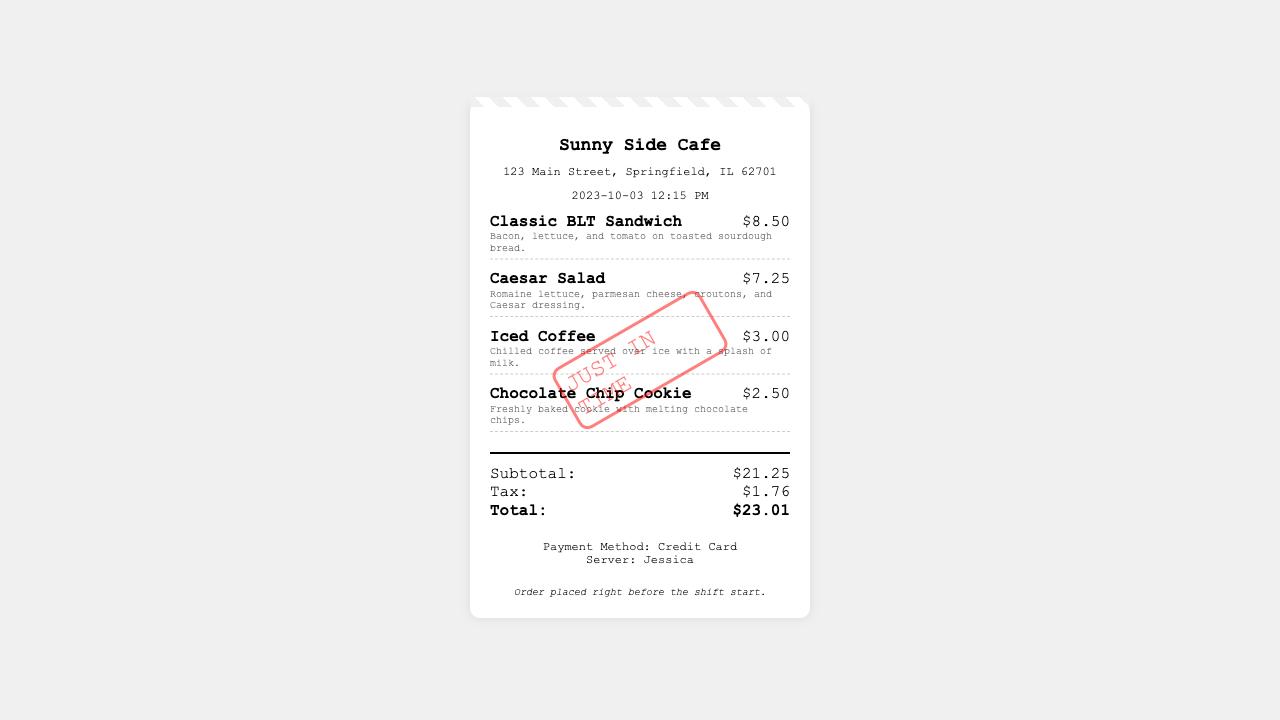What is the name of the cafe? The name of the cafe is prominently displayed at the top of the receipt.
Answer: Sunny Side Cafe What is the address of the cafe? The address is provided directly below the cafe's name.
Answer: 123 Main Street, Springfield, IL 62701 What is the date and time of the order? The date and time are specified below the cafe's address.
Answer: 2023-10-03 12:15 PM How much did the Classic BLT Sandwich cost? The cost of the Classic BLT Sandwich is listed next to the item description.
Answer: $8.50 What is the total amount due? The total amount is clearly labeled at the bottom of the receipt in the totals section.
Answer: $23.01 What payment method was used? The payment method is noted in the payment info section.
Answer: Credit Card Who served the order? The server's name is mentioned in the payment info section.
Answer: Jessica What is the subtotal before tax? The subtotal is provided before the tax amount in the totals section.
Answer: $21.25 What notes are included at the bottom of the receipt? The notes convey additional information regarding the order procedure.
Answer: Order placed right before the shift start 